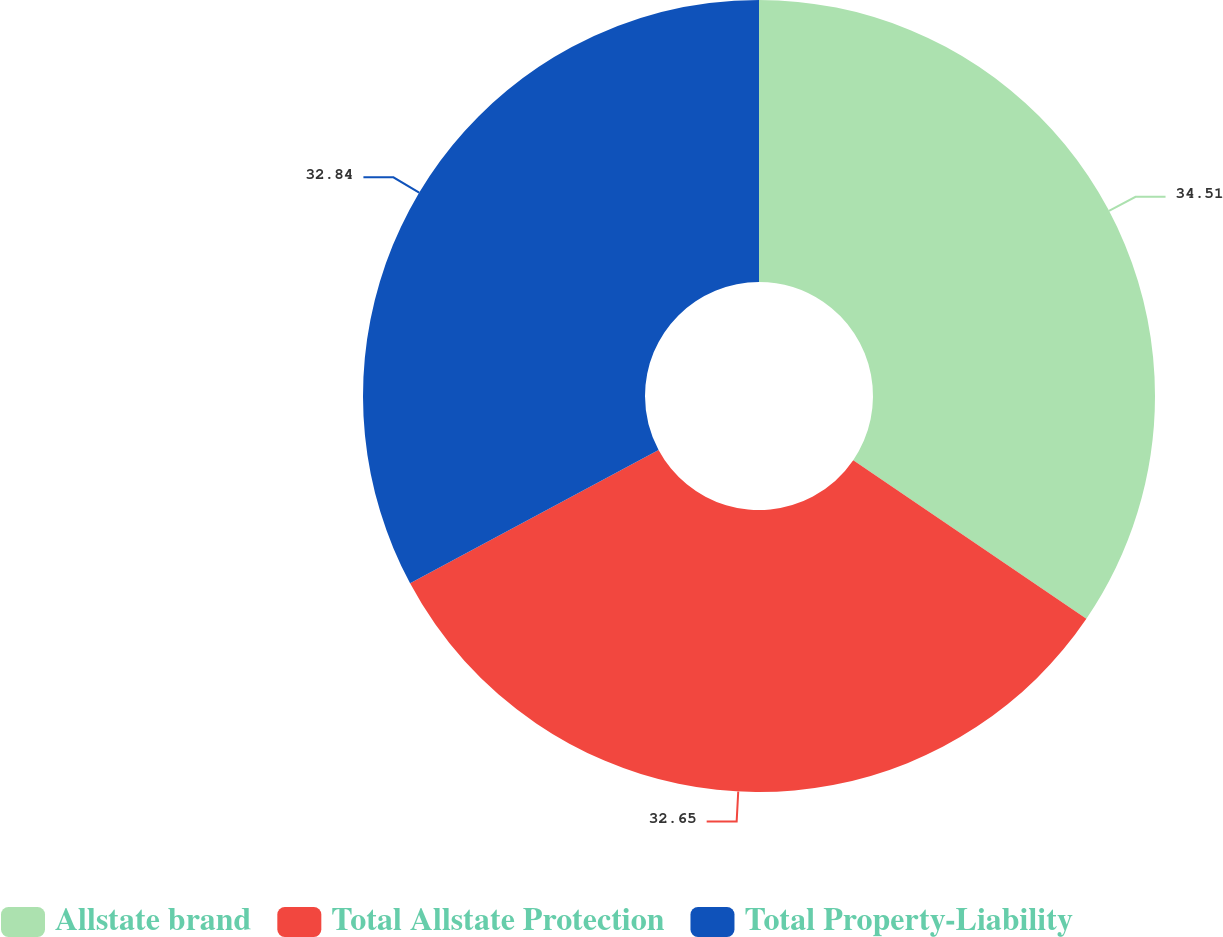Convert chart to OTSL. <chart><loc_0><loc_0><loc_500><loc_500><pie_chart><fcel>Allstate brand<fcel>Total Allstate Protection<fcel>Total Property-Liability<nl><fcel>34.51%<fcel>32.65%<fcel>32.84%<nl></chart> 